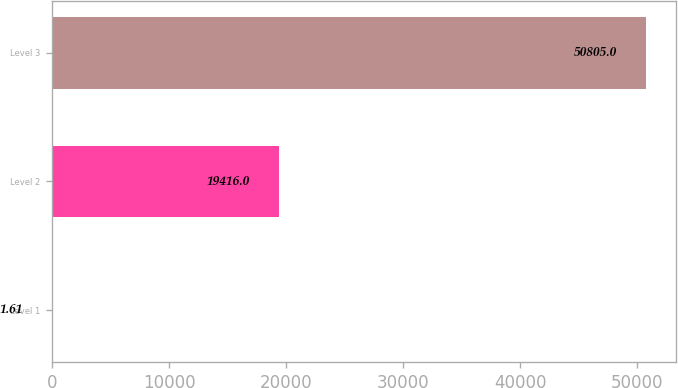Convert chart to OTSL. <chart><loc_0><loc_0><loc_500><loc_500><bar_chart><fcel>Level 1<fcel>Level 2<fcel>Level 3<nl><fcel>1.61<fcel>19416<fcel>50805<nl></chart> 